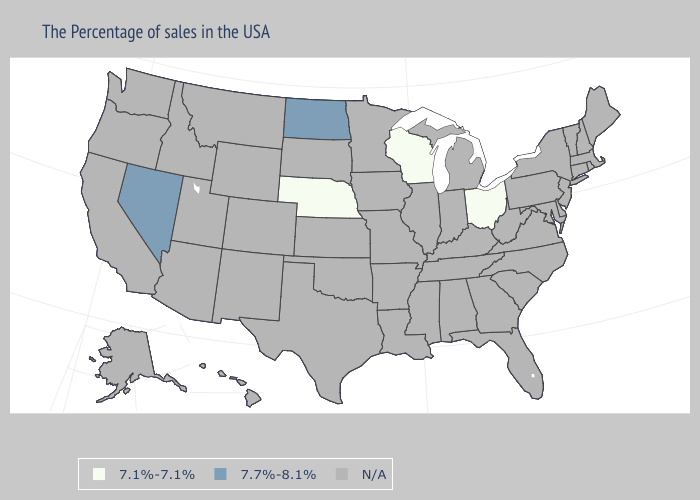Does the map have missing data?
Be succinct. Yes. Which states have the lowest value in the USA?
Be succinct. Ohio, Wisconsin, Nebraska. What is the lowest value in the USA?
Answer briefly. 7.1%-7.1%. What is the value of Illinois?
Keep it brief. N/A. What is the value of West Virginia?
Write a very short answer. N/A. What is the value of Texas?
Concise answer only. N/A. Does North Dakota have the highest value in the USA?
Keep it brief. Yes. What is the value of Tennessee?
Give a very brief answer. N/A. What is the value of Maine?
Write a very short answer. N/A. What is the value of Vermont?
Answer briefly. N/A. 